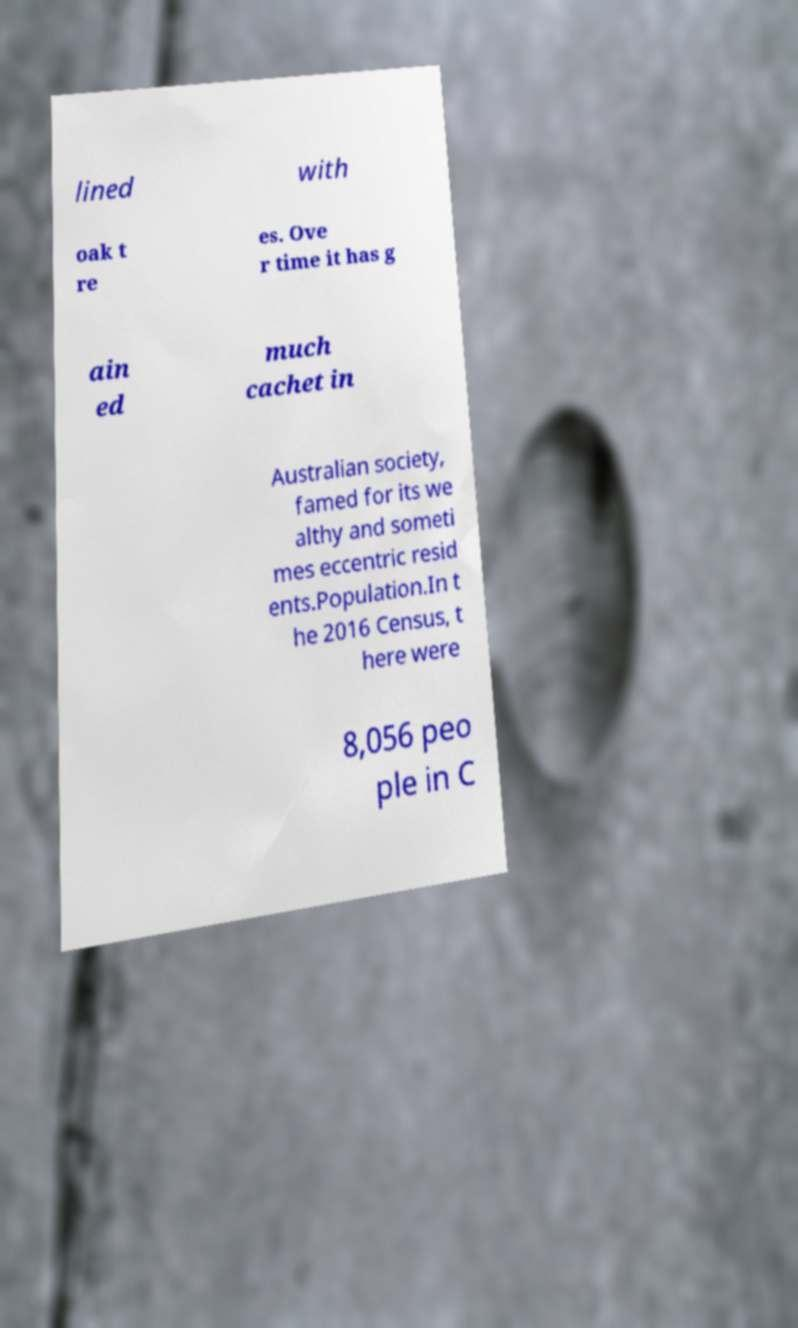What messages or text are displayed in this image? I need them in a readable, typed format. lined with oak t re es. Ove r time it has g ain ed much cachet in Australian society, famed for its we althy and someti mes eccentric resid ents.Population.In t he 2016 Census, t here were 8,056 peo ple in C 